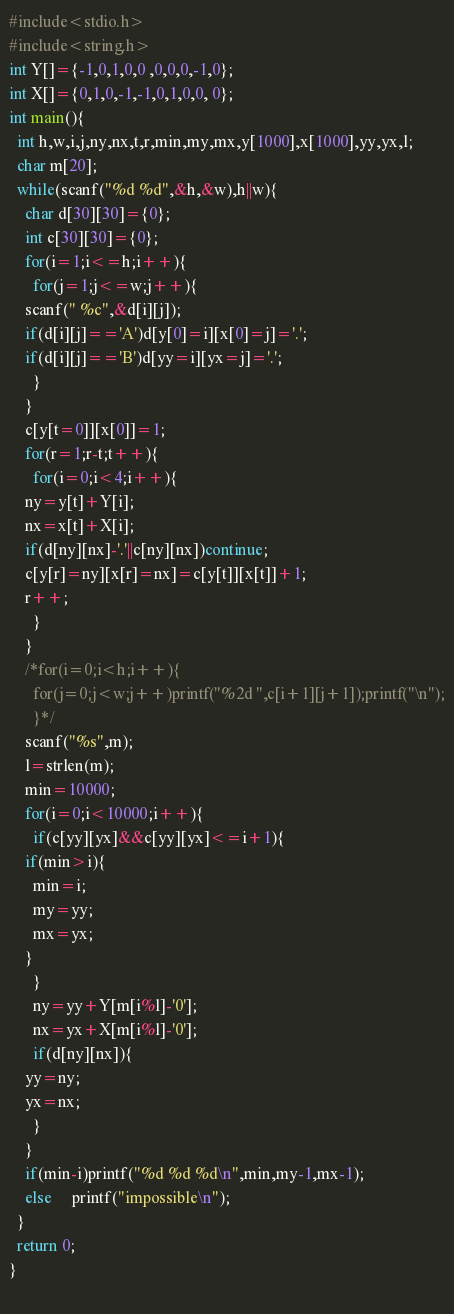Convert code to text. <code><loc_0><loc_0><loc_500><loc_500><_C_>#include<stdio.h>
#include<string.h>
int Y[]={-1,0,1,0,0 ,0,0,0,-1,0};
int X[]={0,1,0,-1,-1,0,1,0,0, 0};
int main(){
  int h,w,i,j,ny,nx,t,r,min,my,mx,y[1000],x[1000],yy,yx,l;
  char m[20];
  while(scanf("%d %d",&h,&w),h||w){
    char d[30][30]={0};
    int c[30][30]={0};
    for(i=1;i<=h;i++){
      for(j=1;j<=w;j++){
	scanf(" %c",&d[i][j]);
	if(d[i][j]=='A')d[y[0]=i][x[0]=j]='.';
	if(d[i][j]=='B')d[yy=i][yx=j]='.';
      }
    }
    c[y[t=0]][x[0]]=1;
    for(r=1;r-t;t++){
      for(i=0;i<4;i++){
	ny=y[t]+Y[i];
	nx=x[t]+X[i];
	if(d[ny][nx]-'.'||c[ny][nx])continue;
	c[y[r]=ny][x[r]=nx]=c[y[t]][x[t]]+1;
	r++;
      }
    }
    /*for(i=0;i<h;i++){
      for(j=0;j<w;j++)printf("%2d ",c[i+1][j+1]);printf("\n");
      }*/
    scanf("%s",m);
    l=strlen(m);
    min=10000;
    for(i=0;i<10000;i++){
      if(c[yy][yx]&&c[yy][yx]<=i+1){
	if(min>i){
	  min=i;
	  my=yy;
	  mx=yx;
	}
      }
      ny=yy+Y[m[i%l]-'0'];
      nx=yx+X[m[i%l]-'0'];
      if(d[ny][nx]){
	yy=ny;
	yx=nx;
      }
    }
    if(min-i)printf("%d %d %d\n",min,my-1,mx-1);
    else     printf("impossible\n");
  }
  return 0;
}
    </code> 